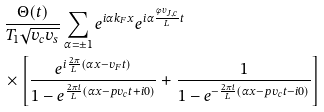Convert formula to latex. <formula><loc_0><loc_0><loc_500><loc_500>& \frac { \Theta ( t ) } { T _ { 1 } \sqrt { v _ { c } v _ { s } } } \sum _ { \alpha = \pm 1 } e ^ { i \alpha k _ { F } x } e ^ { i \alpha \frac { \phi v _ { J , c } } { L } t } \\ & \times \left [ \frac { e ^ { i \frac { 2 \pi } { L } ( \alpha x - v _ { F } t ) } } { 1 - e ^ { \frac { 2 \pi i } { L } ( \alpha x - p v _ { c } t + i 0 ) } } + \frac { 1 } { 1 - e ^ { - \frac { 2 \pi i } { L } ( \alpha x - p v _ { c } t - i 0 ) } } \right ]</formula> 